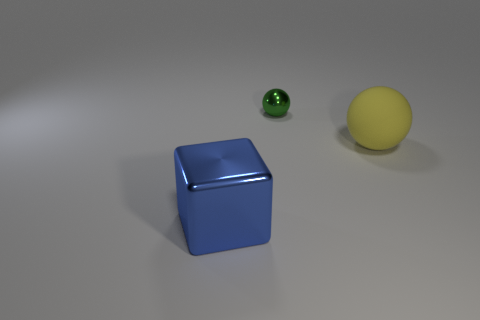Add 3 large objects. How many objects exist? 6 Subtract all cubes. How many objects are left? 2 Subtract 0 gray cylinders. How many objects are left? 3 Subtract all blocks. Subtract all large blue metal objects. How many objects are left? 1 Add 3 metallic things. How many metallic things are left? 5 Add 2 large cubes. How many large cubes exist? 3 